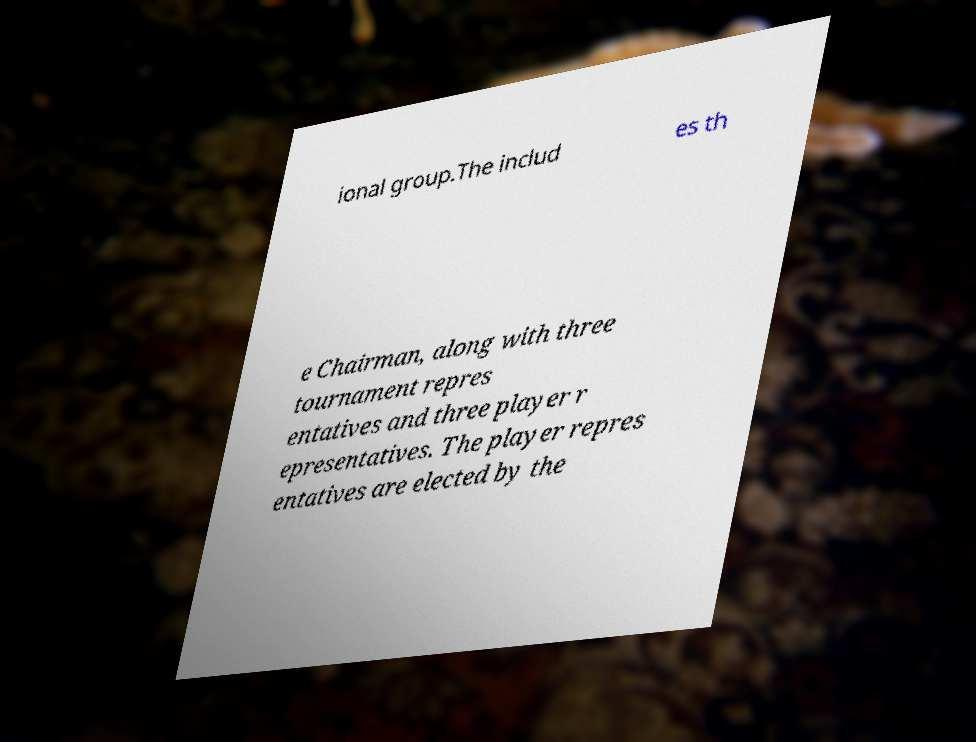Could you assist in decoding the text presented in this image and type it out clearly? ional group.The includ es th e Chairman, along with three tournament repres entatives and three player r epresentatives. The player repres entatives are elected by the 